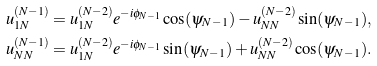Convert formula to latex. <formula><loc_0><loc_0><loc_500><loc_500>u ^ { ( N - 1 ) } _ { 1 N } & = u ^ { ( N - 2 ) } _ { 1 N } e ^ { - i \phi _ { N - 1 } } \cos ( \psi _ { N - 1 } ) - u ^ { ( N - 2 ) } _ { N N } \sin ( \psi _ { N - 1 } ) , \\ u ^ { ( N - 1 ) } _ { N N } & = u ^ { ( N - 2 ) } _ { 1 N } e ^ { - i \phi _ { N - 1 } } \sin ( \psi _ { N - 1 } ) + u ^ { ( N - 2 ) } _ { N N } \cos ( \psi _ { N - 1 } ) .</formula> 